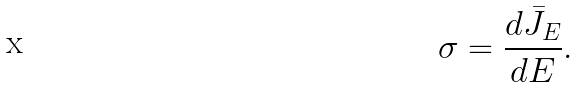<formula> <loc_0><loc_0><loc_500><loc_500>\sigma = \frac { d \bar { J } _ { E } } { d E } .</formula> 